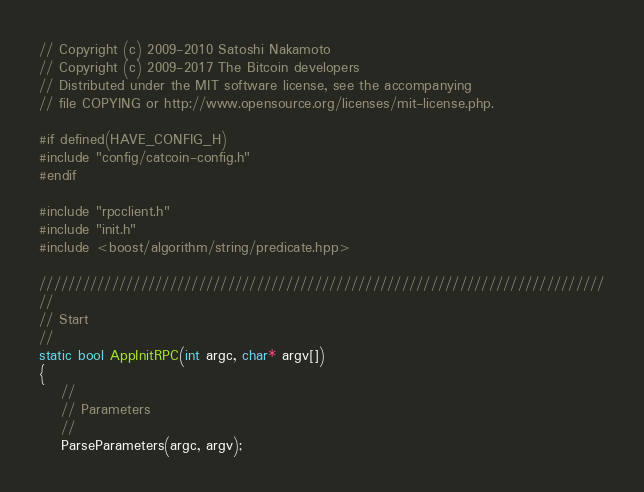Convert code to text. <code><loc_0><loc_0><loc_500><loc_500><_C++_>
// Copyright (c) 2009-2010 Satoshi Nakamoto
// Copyright (c) 2009-2017 The Bitcoin developers
// Distributed under the MIT software license, see the accompanying
// file COPYING or http://www.opensource.org/licenses/mit-license.php.

#if defined(HAVE_CONFIG_H)
#include "config/catcoin-config.h"
#endif

#include "rpcclient.h"
#include "init.h"
#include <boost/algorithm/string/predicate.hpp>

//////////////////////////////////////////////////////////////////////////////
//
// Start
//
static bool AppInitRPC(int argc, char* argv[])
{
    //
    // Parameters
    //
    ParseParameters(argc, argv);
</code> 